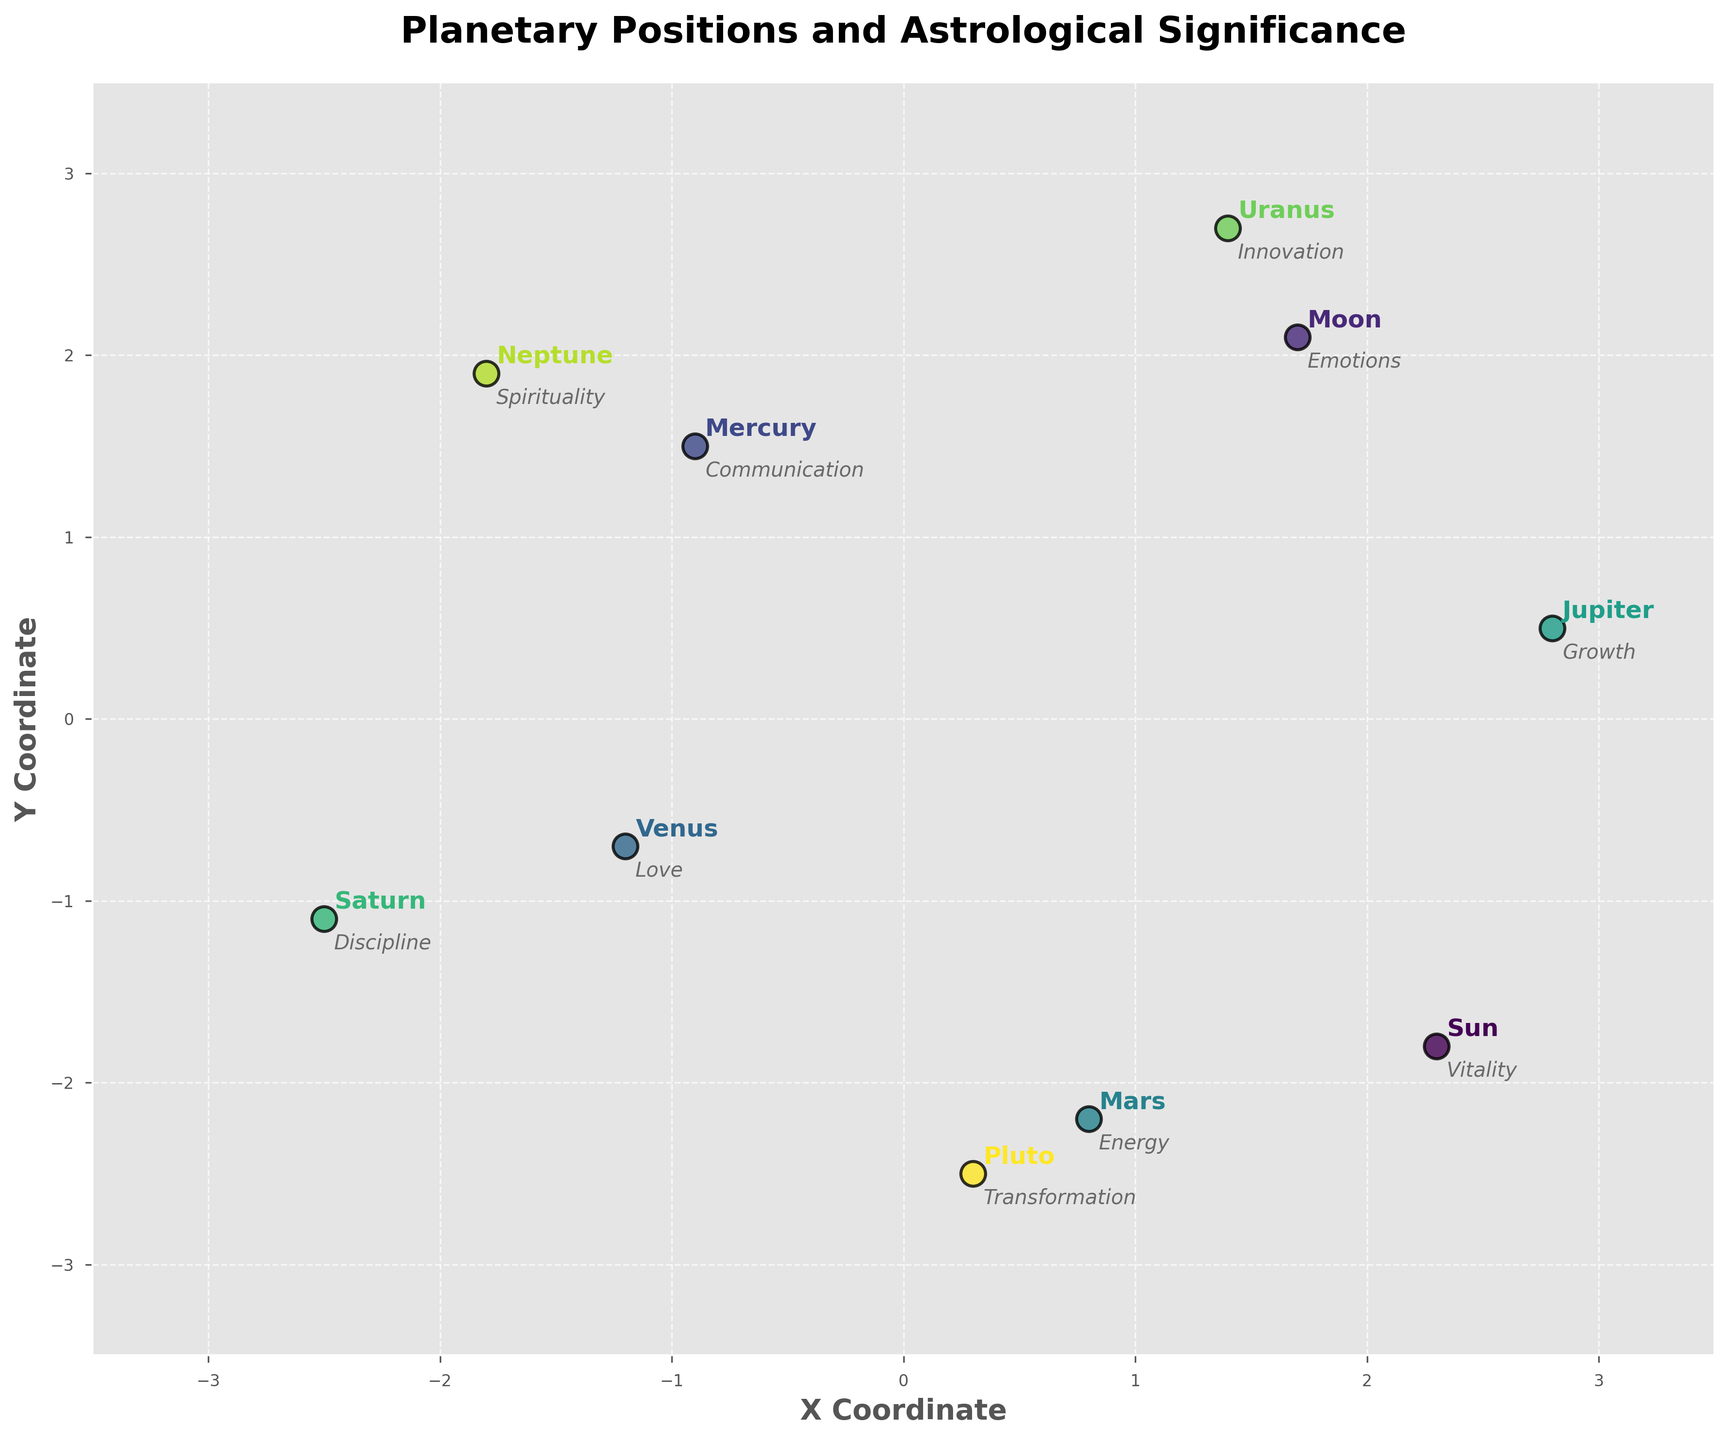what are the x and y coordinates for the planet Mars? The plot shows the x and y coordinates directly next to each planet's name. For Mars, the plotted coordinates are provided.
Answer: x = 0.8, y = -2.2 What is the title of the figure? The title of the figure is typically displayed at the top center of the plot.
Answer: Planetary Positions and Astrological Significance Which planets have a positive x coordinate? By observing the x coordinates on the plot, we see that Sun, Moon, Mars, Jupiter, Uranus, and Pluto have positive x coordinates.
Answer: Sun, Moon, Mars, Jupiter, Uranus, Pluto Which astrological significance is found at the highest positive y coordinate? By checking the y coordinates, the highest positive y coordinate is for Uranus. The astrological significance of Uranus is Innovation.
Answer: Innovation Which planet is closest to the origin (0,0)? Calculate the distance of each planet from the origin using the formula sqrt(x^2 + y^2) and compare. Moon (sqrt(1.7^2 + 2.1^2)=2.7) has the smallest distance.
Answer: Moon How many planets have an astrological significance related to personal traits (vitality, emotions, love, communication)? The personal traits mentioned are vitality (Sun), emotions (Moon), love (Venus), and communication (Mercury). Count these planets on the plot.
Answer: Four planets Compare the x and y coordinates of Jupiter and Saturn. Which planet is further along the x axis? Jupiter's x coordinate is 2.8 and Saturn's is -2.5; therefore, Jupiter is further right on the x axis.
Answer: Jupiter Which planet associated with discipline has a negative x coordinate and falls in the lower left quadrant? The planet associated with discipline is Saturn. By looking at the plot, we confirm Saturn's coordinates (-2.5, -1.1) place it in the lower left quadrant.
Answer: Saturn What is the combined y coordinate of Uranus and Neptune? Add Uranus' y coordinate (2.7) to Neptune's y coordinate (1.9). The combined y coordinate is 2.7 + 1.9.
Answer: 4.6 Identify the planet located at approximately (2.3, -1.8) and its astrological significance. By inspecting the plot, the planet at the specified coordinates (2.3, -1.8) is the Sun, and its astrological significance is Vitality.
Answer: Sun, Vitality 